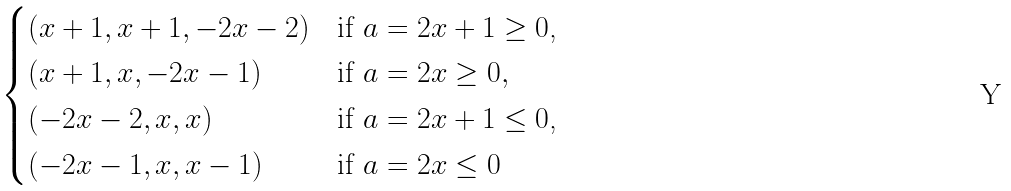<formula> <loc_0><loc_0><loc_500><loc_500>\begin{cases} ( x + 1 , x + 1 , - 2 x - 2 ) & \text {if $a = 2x+1\geq 0$,} \\ ( x + 1 , x , - 2 x - 1 ) & \text {if $a = 2x \geq 0$} , \\ ( - 2 x - 2 , x , x ) & \text {if $a = 2x+1 \leq 0$,} \\ ( - 2 x - 1 , x , x - 1 ) & \text {if $a=2x \leq 0$} \end{cases}</formula> 